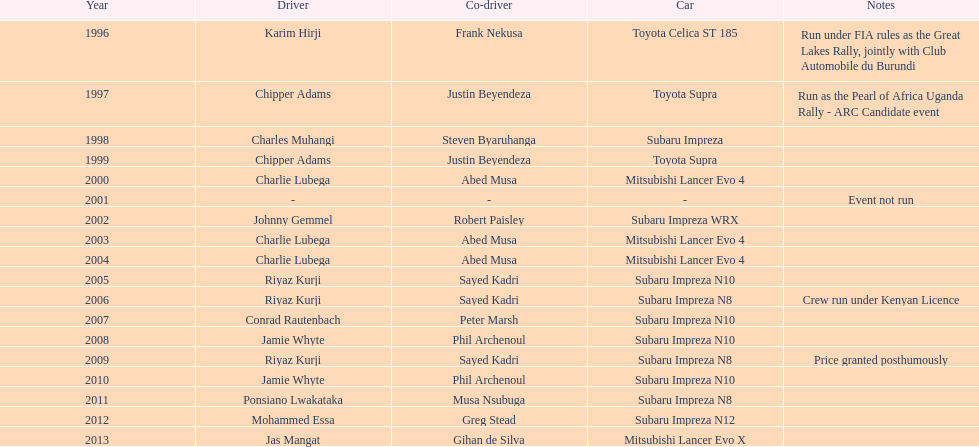How many drivers have achieved victory at least two times? 4. 